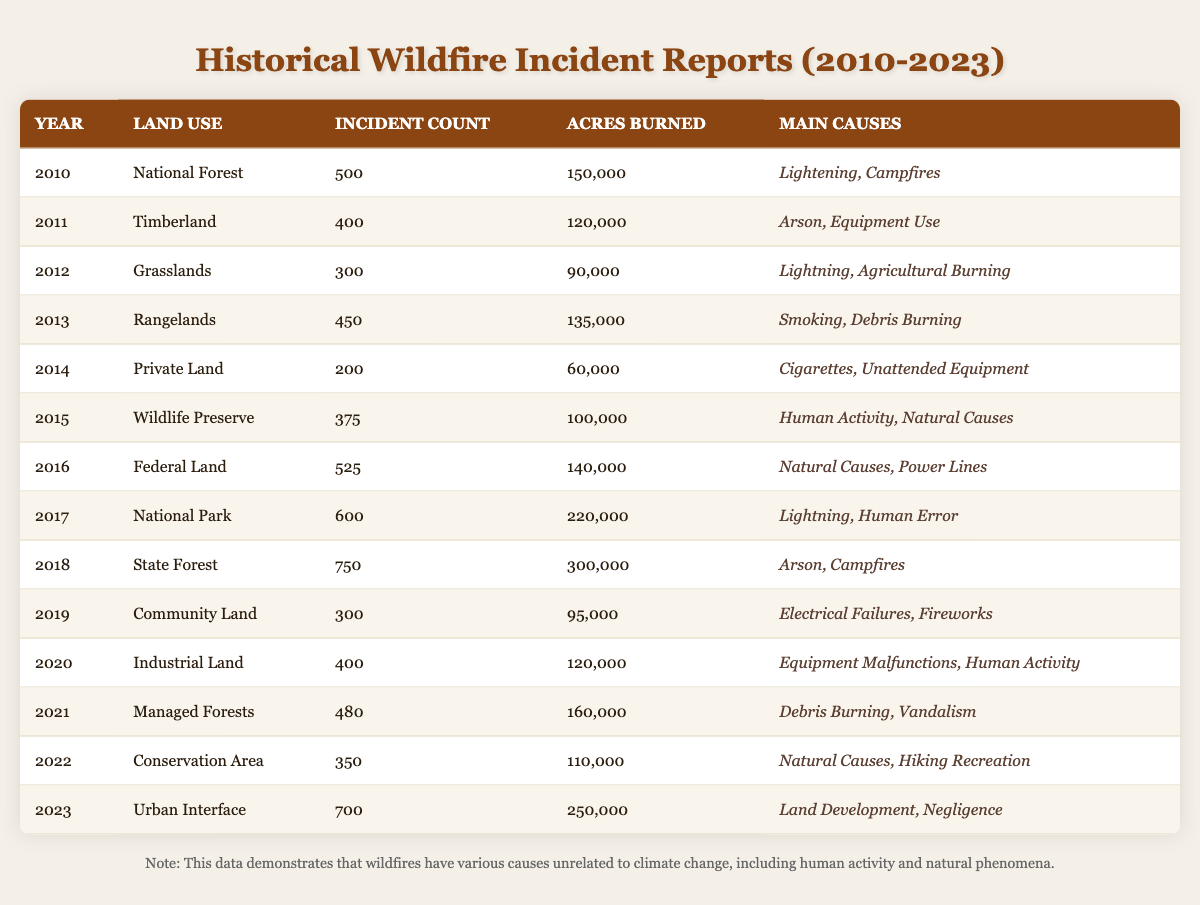What year had the highest incident count of wildfires? By reviewing the incident counts listed for each year, 2018 shows the highest count at 750 wildfires.
Answer: 2018 What is the total number of acres burned from 2010 to 2023? Adding up the acres burned from each year: 150000 + 120000 + 90000 + 135000 + 60000 + 100000 + 140000 + 220000 + 300000 + 95000 + 120000 + 160000 + 110000 + 250000 = 1,735,000 acres.
Answer: 1,735,000 acres In which land use category did the least number of wildfires occur? Upon examining the incident counts, Private Land has the least count with only 200 wildfires in 2014.
Answer: Private Land How many wildfires occurred in total across National Forests and Timberlands? Adding the incident counts for National Forest (500 in 2010) and Timberland (400 in 2011) gives a total of 900 wildfires (500 + 400 = 900).
Answer: 900 Which year had the most acres burned, and what was the amount? Looking through the acres burned, 2018 had the most with 300,000 acres burned.
Answer: 2018, 300,000 acres Are the main causes of wildfires in Conservation Areas ever attributed to human activity? The causes listed for the Conservation Area include "Natural Causes" and "Hiking Recreation," with no reference to human activity, making the statement false.
Answer: No Which land use area had the largest fire incident reporting involving arson? The State Forest in 2018 had 750 wildfires caused primarily by arson.
Answer: State Forest What is the average number of incidents from 2010 to 2023? To find the average, sum all incident counts (500 + 400 + 300 + 450 + 200 + 375 + 525 + 600 + 750 + 300 + 400 + 480 + 350 + 700 = 5,550) and divide by the number of years (14), which results in an average of approximately 396.43 incidents.
Answer: 396.43 Which land use categories had more than 500 wildfires? Checking the counts, National Park in 2017 (600), State Forest in 2018 (750), and Urban Interface in 2023 (700) exceeded 500 wildfires.
Answer: National Park, State Forest, Urban Interface Did natural causes contribute to any wildfires during the years studied? Yes, the causes lists for several years include "Natural Causes," confirming that this is indeed true.
Answer: Yes 